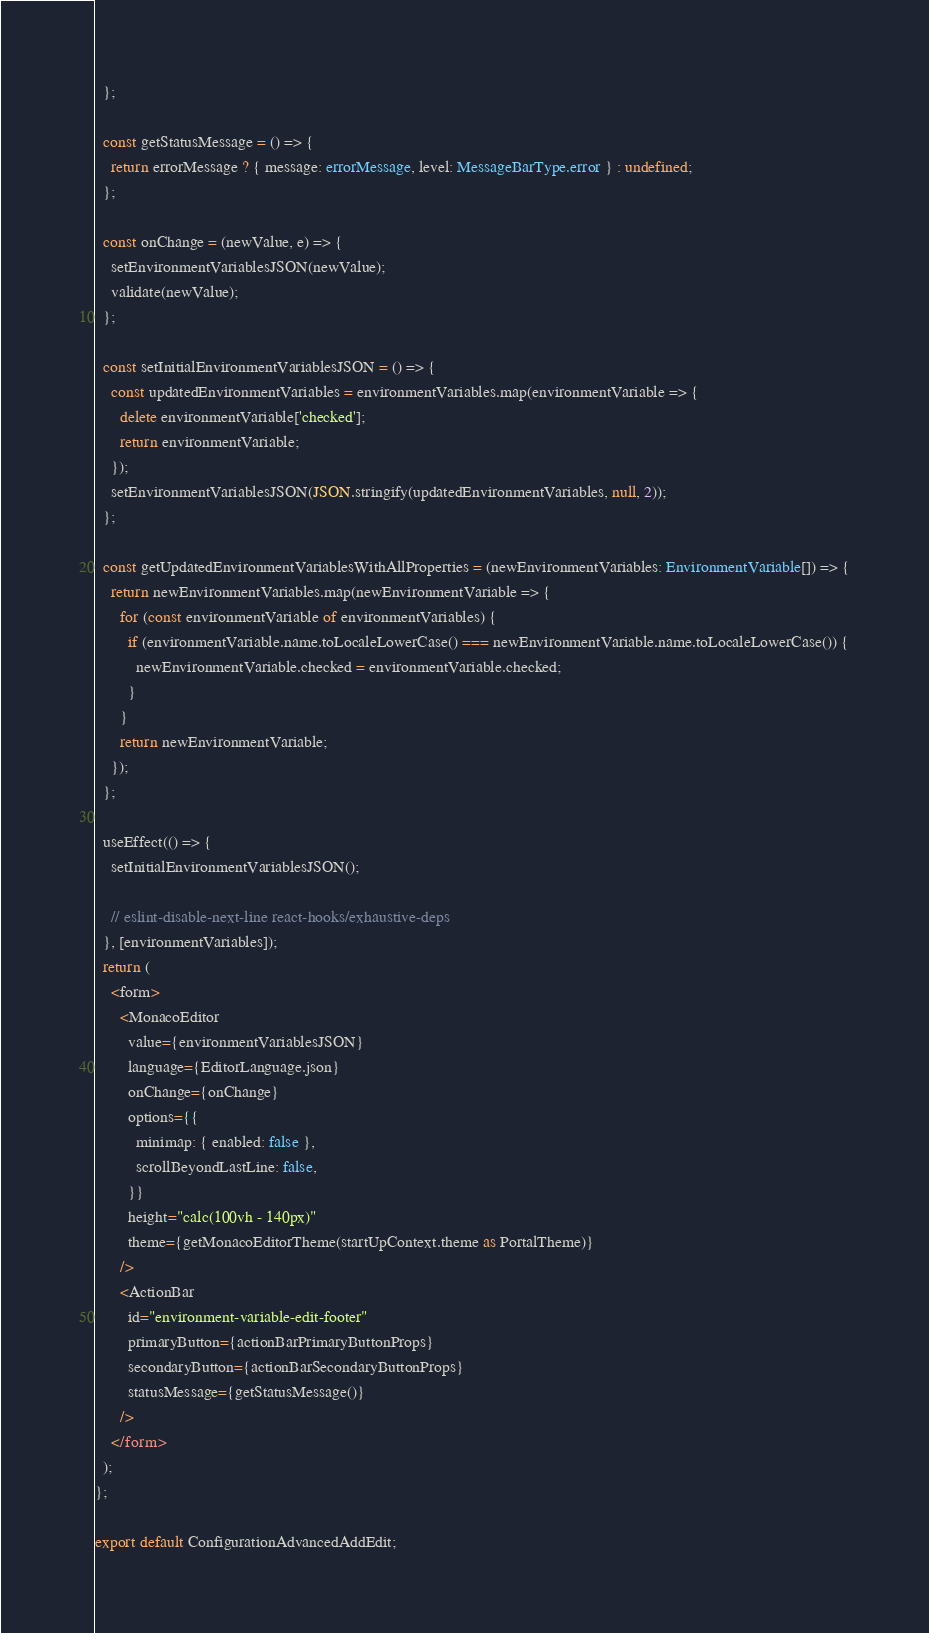<code> <loc_0><loc_0><loc_500><loc_500><_TypeScript_>  };

  const getStatusMessage = () => {
    return errorMessage ? { message: errorMessage, level: MessageBarType.error } : undefined;
  };

  const onChange = (newValue, e) => {
    setEnvironmentVariablesJSON(newValue);
    validate(newValue);
  };

  const setInitialEnvironmentVariablesJSON = () => {
    const updatedEnvironmentVariables = environmentVariables.map(environmentVariable => {
      delete environmentVariable['checked'];
      return environmentVariable;
    });
    setEnvironmentVariablesJSON(JSON.stringify(updatedEnvironmentVariables, null, 2));
  };

  const getUpdatedEnvironmentVariablesWithAllProperties = (newEnvironmentVariables: EnvironmentVariable[]) => {
    return newEnvironmentVariables.map(newEnvironmentVariable => {
      for (const environmentVariable of environmentVariables) {
        if (environmentVariable.name.toLocaleLowerCase() === newEnvironmentVariable.name.toLocaleLowerCase()) {
          newEnvironmentVariable.checked = environmentVariable.checked;
        }
      }
      return newEnvironmentVariable;
    });
  };

  useEffect(() => {
    setInitialEnvironmentVariablesJSON();

    // eslint-disable-next-line react-hooks/exhaustive-deps
  }, [environmentVariables]);
  return (
    <form>
      <MonacoEditor
        value={environmentVariablesJSON}
        language={EditorLanguage.json}
        onChange={onChange}
        options={{
          minimap: { enabled: false },
          scrollBeyondLastLine: false,
        }}
        height="calc(100vh - 140px)"
        theme={getMonacoEditorTheme(startUpContext.theme as PortalTheme)}
      />
      <ActionBar
        id="environment-variable-edit-footer"
        primaryButton={actionBarPrimaryButtonProps}
        secondaryButton={actionBarSecondaryButtonProps}
        statusMessage={getStatusMessage()}
      />
    </form>
  );
};

export default ConfigurationAdvancedAddEdit;
</code> 